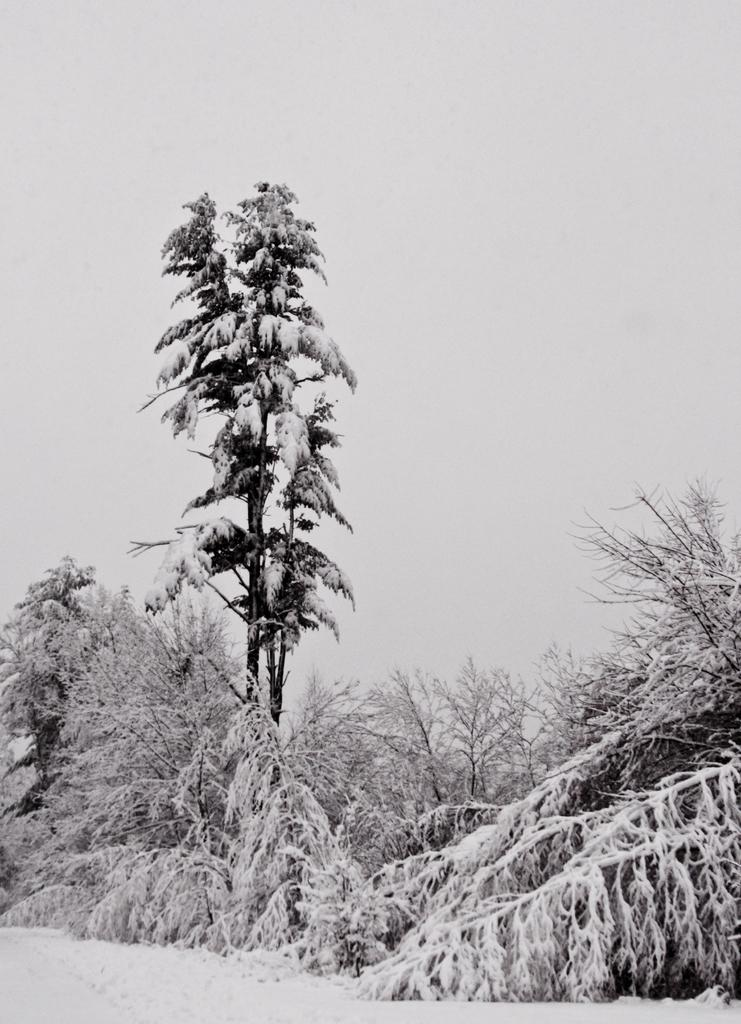What type of environment is depicted at the bottom of the image? The image appears to have a snowy appearance at the bottom. What can be seen in the middle of the image? There are trees in the middle of the image. What is visible at the top of the image? The sky is visible at the top of the image. What color scheme is used in the image? The image is in black and white color. Can you see a baseball player hitting a record in the image? There is no baseball player or record present in the image; it features a snowy environment, trees, and a black and white color scheme. 